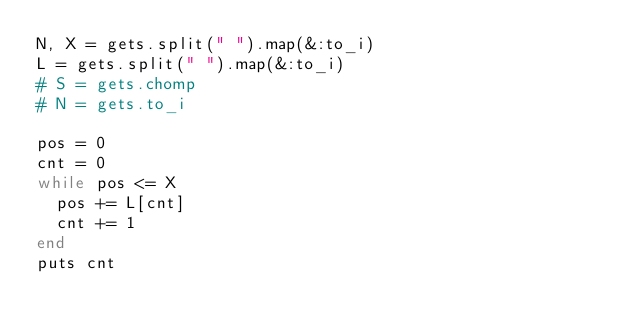Convert code to text. <code><loc_0><loc_0><loc_500><loc_500><_Ruby_>N, X = gets.split(" ").map(&:to_i)
L = gets.split(" ").map(&:to_i)
# S = gets.chomp
# N = gets.to_i

pos = 0
cnt = 0
while pos <= X
  pos += L[cnt]
  cnt += 1
end
puts cnt
</code> 